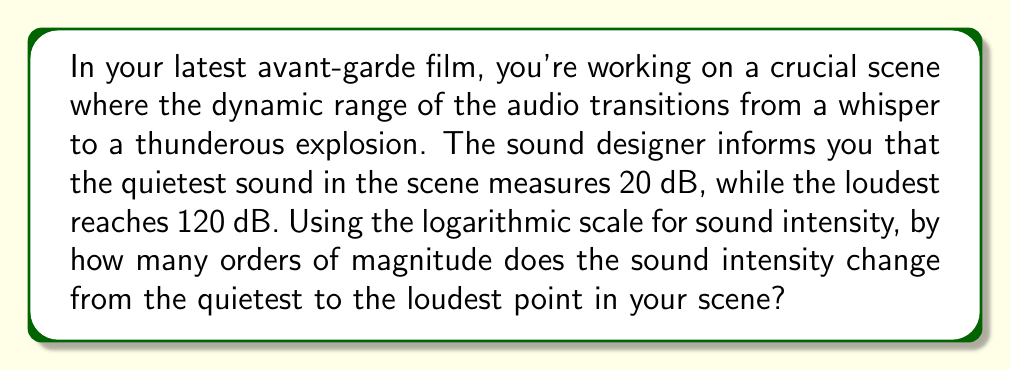Provide a solution to this math problem. Let's approach this step-by-step:

1) The decibel (dB) scale is a logarithmic scale used to measure sound intensity. The relationship between sound intensity (I) and decibels (dB) is given by the equation:

   $$dB = 10 \log_{10}\left(\frac{I}{I_0}\right)$$

   where $I_0$ is the reference intensity.

2) We're interested in the ratio of intensities between the loudest and quietest sounds. Let's call the intensity of the quietest sound $I_1$ and the loudest $I_2$. We can write two equations:

   $$20 = 10 \log_{10}\left(\frac{I_1}{I_0}\right)$$
   $$120 = 10 \log_{10}\left(\frac{I_2}{I_0}\right)$$

3) Subtracting these equations:

   $$120 - 20 = 10 \log_{10}\left(\frac{I_2}{I_0}\right) - 10 \log_{10}\left(\frac{I_1}{I_0}\right)$$

4) Using the logarithm property $\log(a) - \log(b) = \log(a/b)$:

   $$100 = 10 \log_{10}\left(\frac{I_2/I_0}{I_1/I_0}\right) = 10 \log_{10}\left(\frac{I_2}{I_1}\right)$$

5) Dividing both sides by 10:

   $$10 = \log_{10}\left(\frac{I_2}{I_1}\right)$$

6) Taking $10^x$ of both sides:

   $$10^{10} = \frac{I_2}{I_1}$$

7) $10^{10}$ is equal to 10 billion, or $10^{10} = 10,000,000,000$

This means the intensity of the loudest sound is 10 billion times greater than the quietest sound. In terms of orders of magnitude, this is a change of 10 orders of magnitude.
Answer: 10 orders of magnitude 